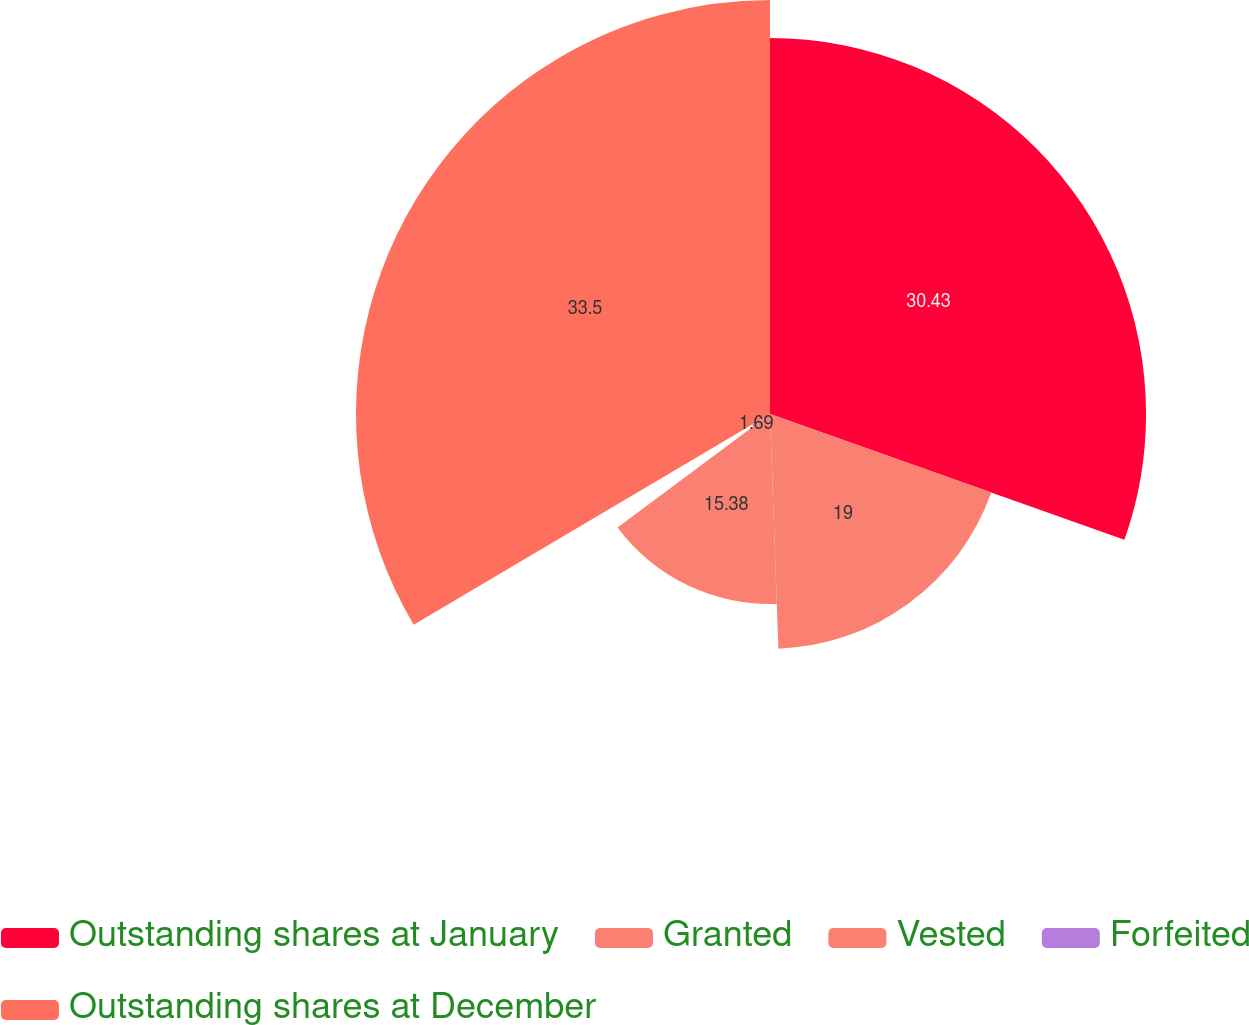<chart> <loc_0><loc_0><loc_500><loc_500><pie_chart><fcel>Outstanding shares at January<fcel>Granted<fcel>Vested<fcel>Forfeited<fcel>Outstanding shares at December<nl><fcel>30.43%<fcel>19.0%<fcel>15.38%<fcel>1.69%<fcel>33.5%<nl></chart> 